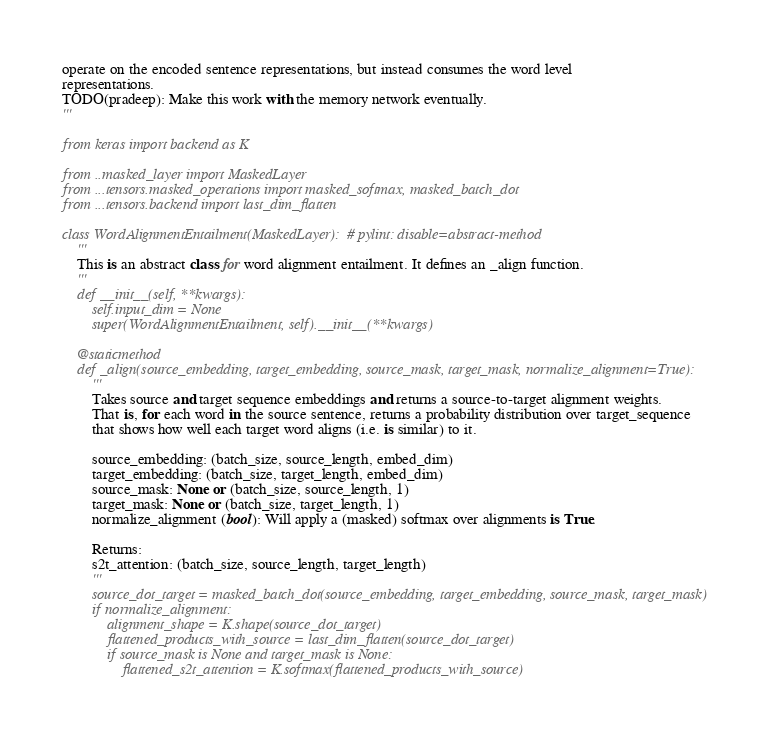<code> <loc_0><loc_0><loc_500><loc_500><_Python_>operate on the encoded sentence representations, but instead consumes the word level
representations.
TODO(pradeep): Make this work with the memory network eventually.
'''

from keras import backend as K

from ..masked_layer import MaskedLayer
from ...tensors.masked_operations import masked_softmax, masked_batch_dot
from ...tensors.backend import last_dim_flatten

class WordAlignmentEntailment(MaskedLayer):  # pylint: disable=abstract-method
    '''
    This is an abstract class for word alignment entailment. It defines an _align function.
    '''
    def __init__(self, **kwargs):
        self.input_dim = None
        super(WordAlignmentEntailment, self).__init__(**kwargs)

    @staticmethod
    def _align(source_embedding, target_embedding, source_mask, target_mask, normalize_alignment=True):
        '''
        Takes source and target sequence embeddings and returns a source-to-target alignment weights.
        That is, for each word in the source sentence, returns a probability distribution over target_sequence
        that shows how well each target word aligns (i.e. is similar) to it.

        source_embedding: (batch_size, source_length, embed_dim)
        target_embedding: (batch_size, target_length, embed_dim)
        source_mask: None or (batch_size, source_length, 1)
        target_mask: None or (batch_size, target_length, 1)
        normalize_alignment (bool): Will apply a (masked) softmax over alignments is True.

        Returns:
        s2t_attention: (batch_size, source_length, target_length)
        '''
        source_dot_target = masked_batch_dot(source_embedding, target_embedding, source_mask, target_mask)
        if normalize_alignment:
            alignment_shape = K.shape(source_dot_target)
            flattened_products_with_source = last_dim_flatten(source_dot_target)
            if source_mask is None and target_mask is None:
                flattened_s2t_attention = K.softmax(flattened_products_with_source)</code> 